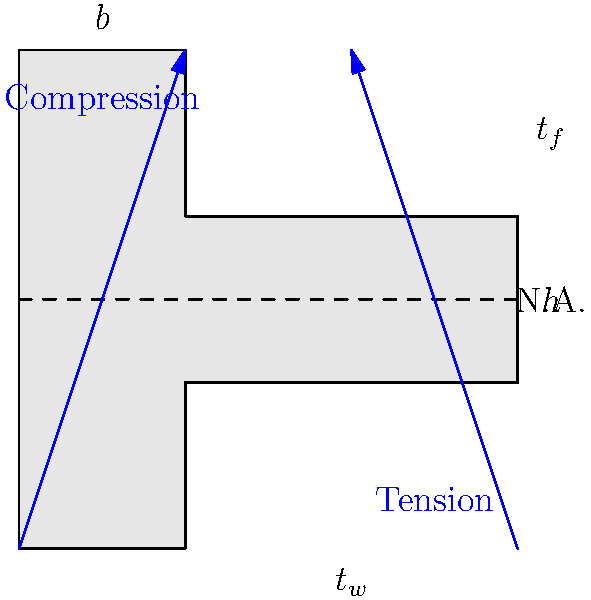As a novelist who often incorporates engineering concepts into your stories, you've come across a scenario involving an I-beam. Given an I-beam with height $h$, flange width $b$, web thickness $t_w$, and flange thickness $t_f$, how would you express the moment of inertia $I$ about the neutral axis in terms of these dimensions? To calculate the moment of inertia for an I-beam, we'll follow these steps:

1. Divide the I-beam into three rectangles: two flanges and one web.

2. Calculate the moment of inertia for each rectangle:
   - For a rectangle: $I = \frac{1}{12}bh^3$
   
3. For the top and bottom flanges:
   $I_f = 2 \cdot \frac{1}{12}b(t_f)^3$

4. For the web:
   $I_w = \frac{1}{12}t_w(h-2t_f)^3$

5. Apply the parallel axis theorem to account for the distance of the flanges from the neutral axis:
   $I_{parallel} = I + Ad^2$
   where $A$ is the area of the rectangle and $d$ is the distance from its centroid to the neutral axis.

6. For the flanges:
   $I_{f,parallel} = 2 \cdot [I_f + bt_f(\frac{h-t_f}{2})^2]$

7. The total moment of inertia is the sum of all components:
   $I_{total} = I_{f,parallel} + I_w$

8. Substituting and simplifying:

   $$I = 2 \cdot [\frac{1}{12}bt_f^3 + bt_f(\frac{h-t_f}{2})^2] + \frac{1}{12}t_w(h-2t_f)^3$$

   $$I = \frac{1}{12}[2bt_f^3 + 12bt_f(\frac{h-t_f}{2})^2 + t_w(h-2t_f)^3]$$
Answer: $I = \frac{1}{12}[2bt_f^3 + 12bt_f(\frac{h-t_f}{2})^2 + t_w(h-2t_f)^3]$ 